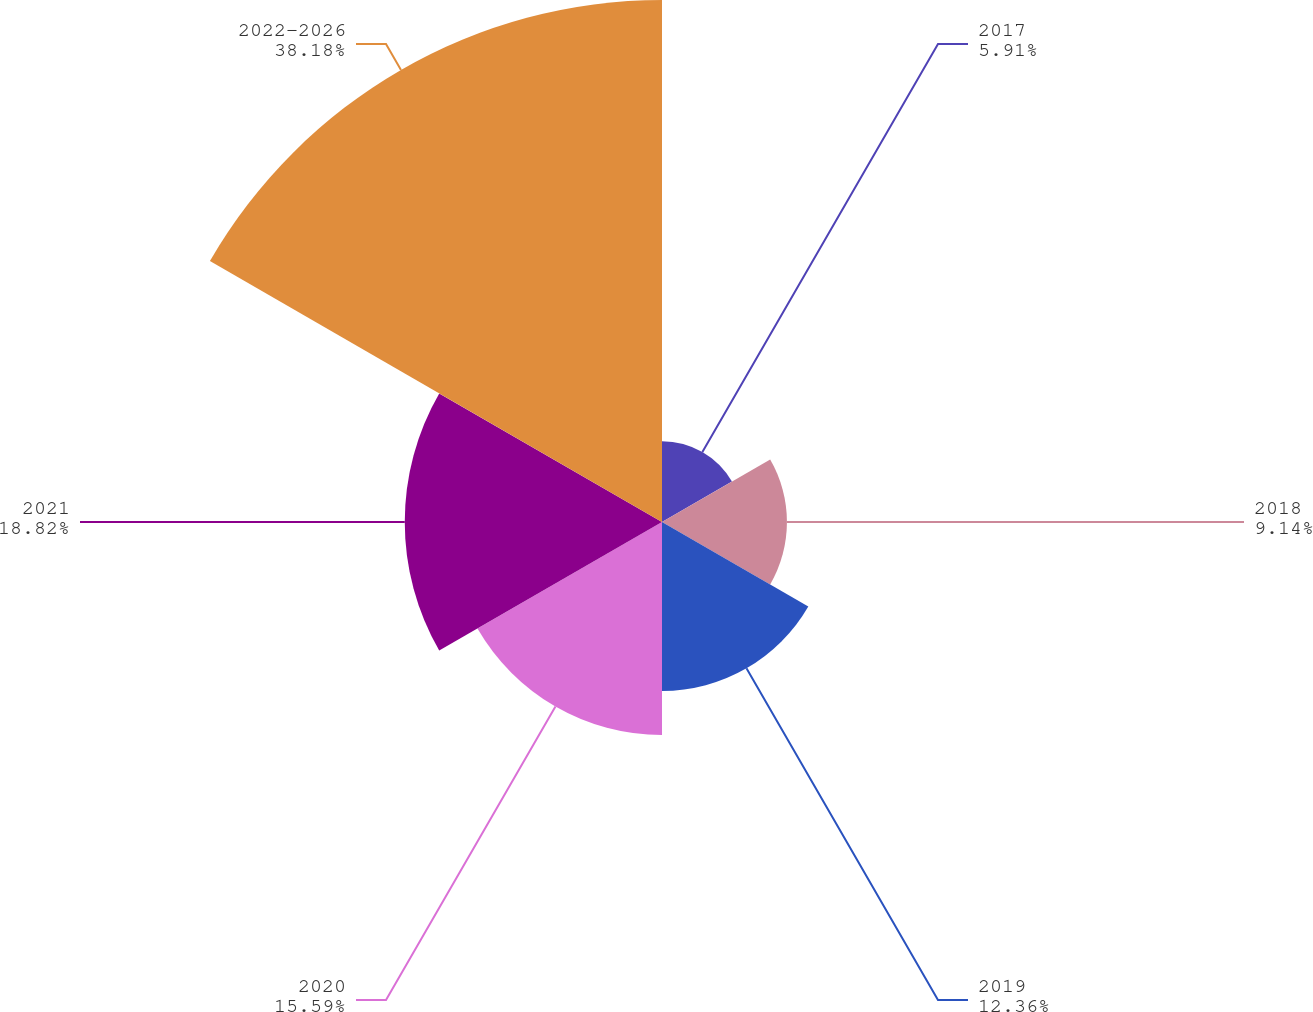<chart> <loc_0><loc_0><loc_500><loc_500><pie_chart><fcel>2017<fcel>2018<fcel>2019<fcel>2020<fcel>2021<fcel>2022-2026<nl><fcel>5.91%<fcel>9.14%<fcel>12.36%<fcel>15.59%<fcel>18.82%<fcel>38.19%<nl></chart> 